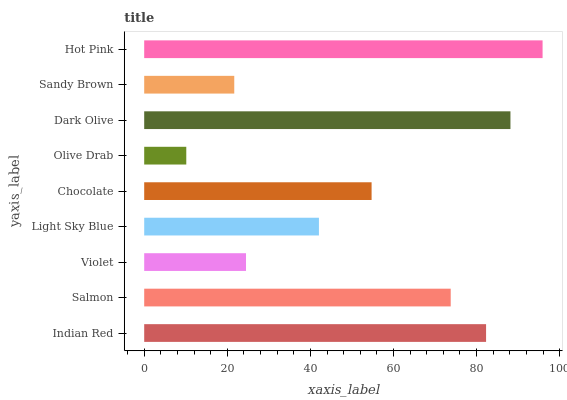Is Olive Drab the minimum?
Answer yes or no. Yes. Is Hot Pink the maximum?
Answer yes or no. Yes. Is Salmon the minimum?
Answer yes or no. No. Is Salmon the maximum?
Answer yes or no. No. Is Indian Red greater than Salmon?
Answer yes or no. Yes. Is Salmon less than Indian Red?
Answer yes or no. Yes. Is Salmon greater than Indian Red?
Answer yes or no. No. Is Indian Red less than Salmon?
Answer yes or no. No. Is Chocolate the high median?
Answer yes or no. Yes. Is Chocolate the low median?
Answer yes or no. Yes. Is Hot Pink the high median?
Answer yes or no. No. Is Indian Red the low median?
Answer yes or no. No. 